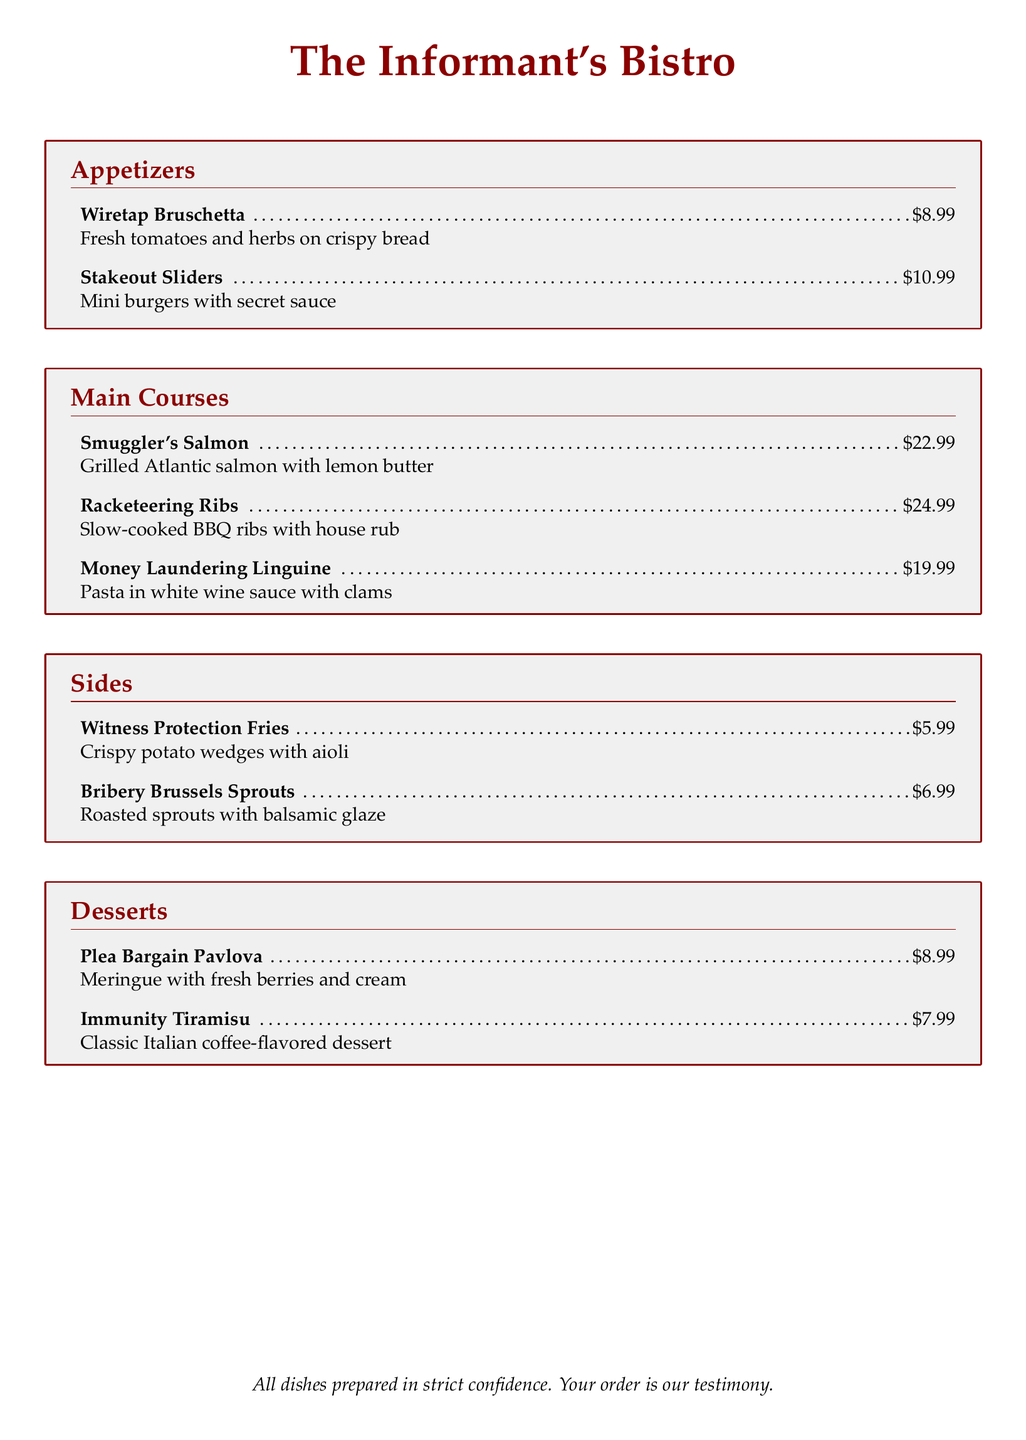What is the price of Wiretap Bruschetta? The price of Wiretap Bruschetta is listed directly in the menu as $8.99.
Answer: $8.99 How many main courses are listed on the menu? The menu contains three options in the main courses section.
Answer: 3 What is the dish that represents money laundering? "Money Laundering Linguine" is the dish that represents money laundering in this menu.
Answer: Money Laundering Linguine What side dish is priced at $6.99? "Bribery Brussels Sprouts" is the side dish that costs $6.99 according to the menu.
Answer: Bribery Brussels Sprouts What is the dessert that includes meringue? The dessert featuring meringue is "Plea Bargain Pavlova" as stated in the desserts section.
Answer: Plea Bargain Pavlova Which main course has the highest price? According to the menu, "Racketeering Ribs" is the main course with the highest price of $24.99.
Answer: Racketeering Ribs What is the total number of appetizers listed? There are two appetizers present in the menu according to the appetizers section.
Answer: 2 What is the dish that includes fresh berries? "Plea Bargain Pavlova" includes fresh berries as part of its description in the dessert section.
Answer: Plea Bargain Pavlova What type of cuisine does this menu represent? The menu represents a unique blend of Italian and themed cuisine based on criminal activity.
Answer: Informant's Bistro 